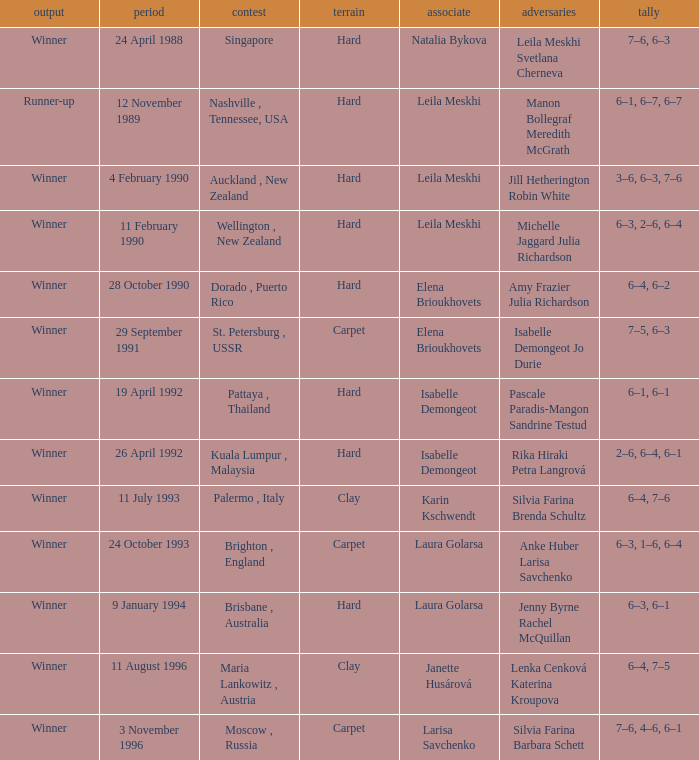Who was the Partner in a game with the Score of 6–4, 6–2 on a hard surface? Elena Brioukhovets. 